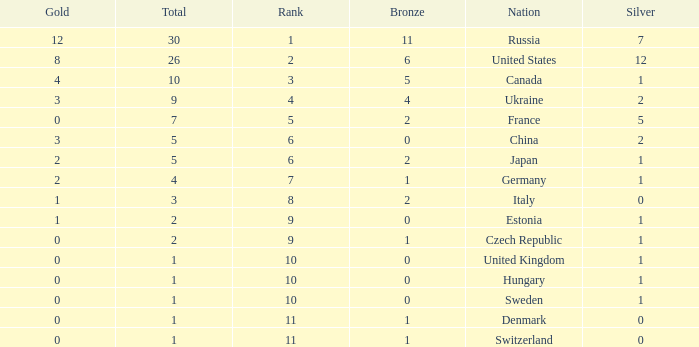Which silver has a Gold smaller than 12, a Rank smaller than 5, and a Bronze of 5? 1.0. 